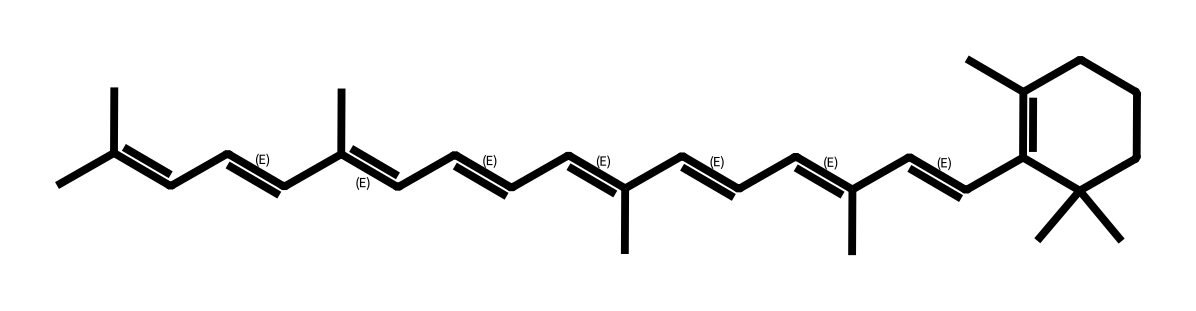What is the molecular formula of retinal? To determine the molecular formula from the SMILES representation, identify the number of carbon (C), hydrogen (H), and any other atoms present. The longest chain contains 20 carbons and 28 hydrogens, leading to the formula C20H28.
Answer: C20H28 How many double bonds are present in this structure? Upon examining the SMILES string, each "/C=C/" represents a double bond. Counting these gives a total of 5 double bonds in the structure.
Answer: 5 What type of isomerism is present in retinal? The presence of double bonds and stereochemical arrangements (E/Z configurations) indicates that retinal exhibits geometric isomerism.
Answer: geometric isomerism Is there a cyclic structure in retinal? The "C1" notation within the SMILES indicates the presence of a cyclic structure, specifically a cyclohexane ring, confirming that retinal has a cyclic component.
Answer: yes What characteristic does retinal provide to vision? Retinal is essential for vision because it acts as a chromophore in the photoreceptors, absorbing light and triggering a photochemical change.
Answer: chromophore How does the geometric configuration affect retinal's function? The geometric isomers of retinal (e.g., all-trans and 11-cis forms) are crucial for its ability to trigger conformational changes in the opsin proteins, underlying the visual cycle.
Answer: critical for function 